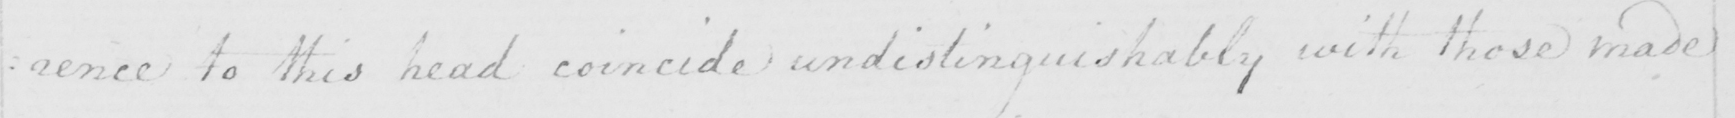What is written in this line of handwriting? : ence to this head coincide undistinguishably with those made 